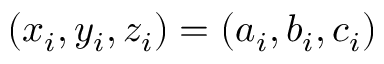Convert formula to latex. <formula><loc_0><loc_0><loc_500><loc_500>( x _ { i } , y _ { i } , z _ { i } ) = ( a _ { i } , b _ { i } , c _ { i } )</formula> 